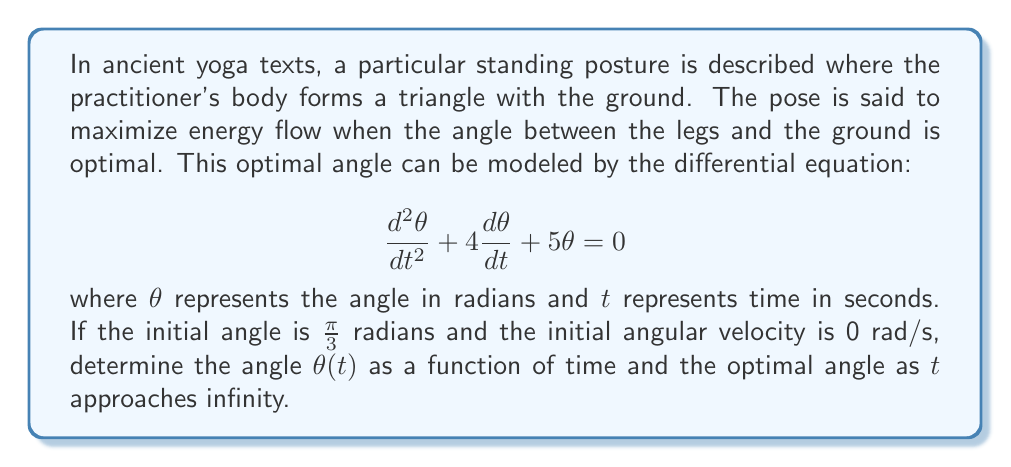Can you answer this question? To solve this problem, we need to follow these steps:

1) First, we recognize this as a second-order linear differential equation with constant coefficients. The characteristic equation is:

   $$r^2 + 4r + 5 = 0$$

2) Solving this quadratic equation:
   $$r = \frac{-4 \pm \sqrt{16 - 20}}{2} = -2 \pm i$$

3) The general solution is therefore:
   $$\theta(t) = e^{-2t}(A\cos t + B\sin t)$$

4) Now we use the initial conditions to find A and B:
   At $t=0$, $\theta(0) = \frac{\pi}{3}$ and $\theta'(0) = 0$

5) From $\theta(0) = \frac{\pi}{3}$:
   $$\frac{\pi}{3} = A$$

6) From $\theta'(0) = 0$:
   $$0 = -2A + B$$
   $$B = 2A = \frac{2\pi}{3}$$

7) Therefore, the particular solution is:
   $$\theta(t) = e^{-2t}(\frac{\pi}{3}\cos t + \frac{2\pi}{3}\sin t)$$

8) As $t$ approaches infinity, $e^{-2t}$ approaches 0, so the optimal angle as $t$ approaches infinity is 0 radians.
Answer: $\theta(t) = e^{-2t}(\frac{\pi}{3}\cos t + \frac{2\pi}{3}\sin t)$

Optimal angle as $t \to \infty$: 0 radians 